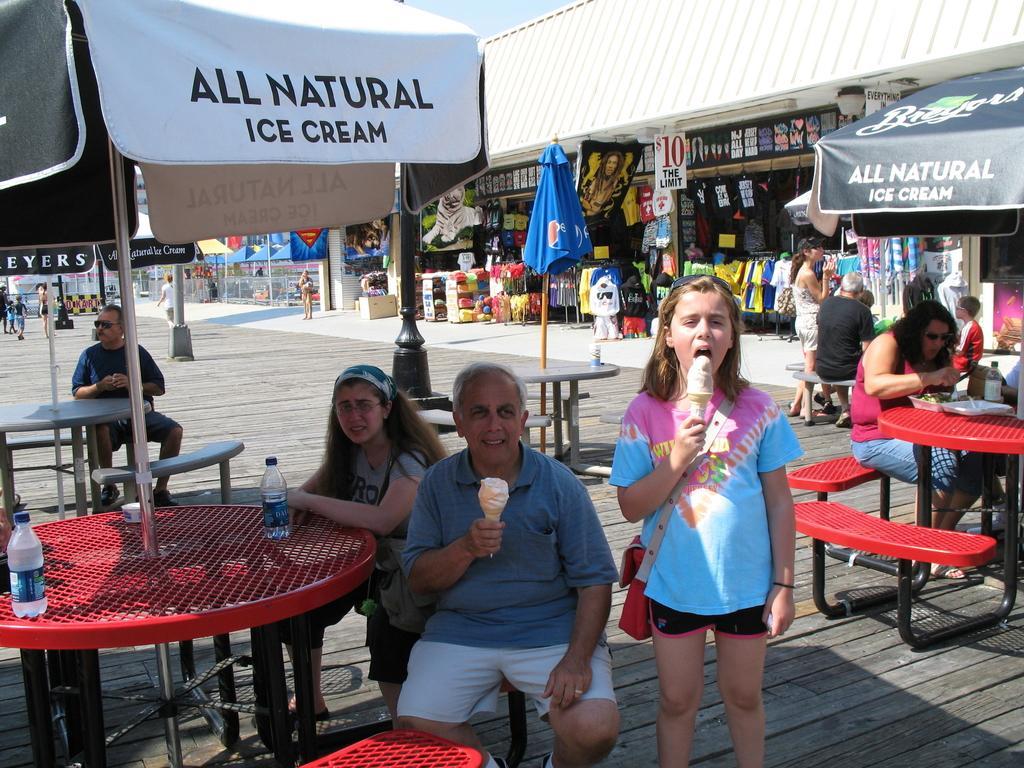Can you describe this image briefly? In this image few people are sitting on the bench. On the table there is a water bottle. The girl is wearing a bag and eating ice-cream. At the back side there are stores. 